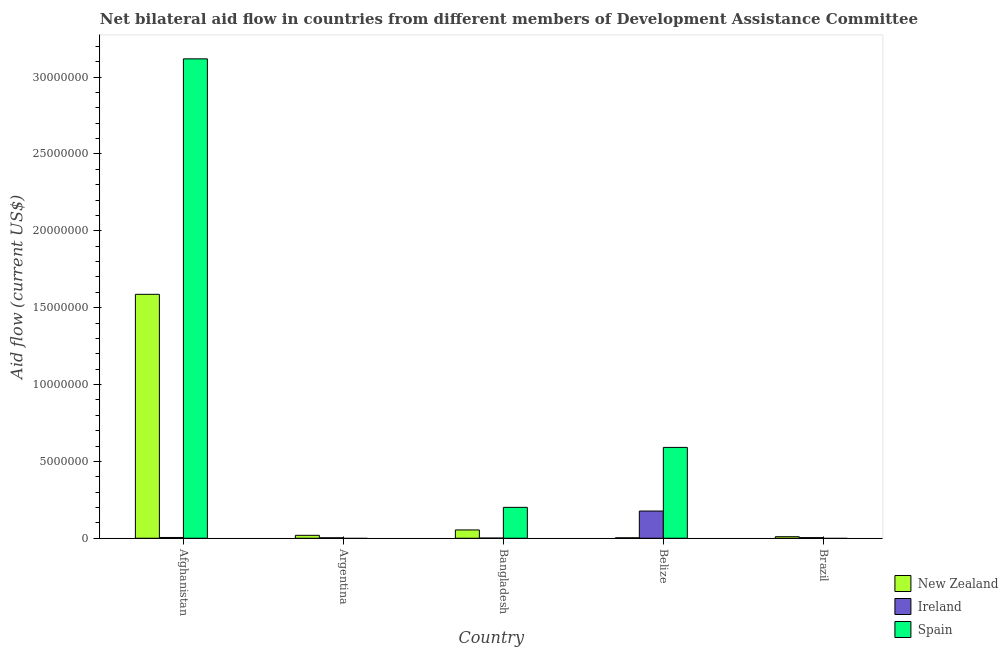How many different coloured bars are there?
Your response must be concise. 3. How many bars are there on the 1st tick from the left?
Offer a very short reply. 3. What is the label of the 5th group of bars from the left?
Ensure brevity in your answer.  Brazil. What is the amount of aid provided by spain in Argentina?
Your answer should be compact. 0. Across all countries, what is the maximum amount of aid provided by new zealand?
Your response must be concise. 1.59e+07. Across all countries, what is the minimum amount of aid provided by ireland?
Keep it short and to the point. 10000. In which country was the amount of aid provided by spain maximum?
Your response must be concise. Afghanistan. What is the total amount of aid provided by spain in the graph?
Keep it short and to the point. 3.91e+07. What is the difference between the amount of aid provided by spain in Afghanistan and that in Bangladesh?
Make the answer very short. 2.92e+07. What is the difference between the amount of aid provided by spain in Afghanistan and the amount of aid provided by new zealand in Bangladesh?
Make the answer very short. 3.06e+07. What is the average amount of aid provided by new zealand per country?
Provide a short and direct response. 3.35e+06. What is the difference between the amount of aid provided by spain and amount of aid provided by ireland in Bangladesh?
Ensure brevity in your answer.  2.00e+06. In how many countries, is the amount of aid provided by new zealand greater than 15000000 US$?
Your answer should be very brief. 1. What is the ratio of the amount of aid provided by new zealand in Afghanistan to that in Belize?
Provide a short and direct response. 529. What is the difference between the highest and the second highest amount of aid provided by new zealand?
Your answer should be compact. 1.53e+07. What is the difference between the highest and the lowest amount of aid provided by spain?
Ensure brevity in your answer.  3.12e+07. In how many countries, is the amount of aid provided by spain greater than the average amount of aid provided by spain taken over all countries?
Give a very brief answer. 1. Is it the case that in every country, the sum of the amount of aid provided by new zealand and amount of aid provided by ireland is greater than the amount of aid provided by spain?
Give a very brief answer. No. How many countries are there in the graph?
Keep it short and to the point. 5. Does the graph contain any zero values?
Keep it short and to the point. Yes. How many legend labels are there?
Ensure brevity in your answer.  3. What is the title of the graph?
Your response must be concise. Net bilateral aid flow in countries from different members of Development Assistance Committee. What is the label or title of the X-axis?
Ensure brevity in your answer.  Country. What is the Aid flow (current US$) of New Zealand in Afghanistan?
Your answer should be very brief. 1.59e+07. What is the Aid flow (current US$) of Ireland in Afghanistan?
Make the answer very short. 5.00e+04. What is the Aid flow (current US$) of Spain in Afghanistan?
Your response must be concise. 3.12e+07. What is the Aid flow (current US$) in New Zealand in Bangladesh?
Keep it short and to the point. 5.40e+05. What is the Aid flow (current US$) in Ireland in Bangladesh?
Keep it short and to the point. 10000. What is the Aid flow (current US$) in Spain in Bangladesh?
Offer a terse response. 2.01e+06. What is the Aid flow (current US$) of Ireland in Belize?
Your response must be concise. 1.77e+06. What is the Aid flow (current US$) of Spain in Belize?
Offer a terse response. 5.91e+06. What is the Aid flow (current US$) of Ireland in Brazil?
Provide a short and direct response. 4.00e+04. Across all countries, what is the maximum Aid flow (current US$) of New Zealand?
Offer a very short reply. 1.59e+07. Across all countries, what is the maximum Aid flow (current US$) of Ireland?
Offer a terse response. 1.77e+06. Across all countries, what is the maximum Aid flow (current US$) in Spain?
Your response must be concise. 3.12e+07. Across all countries, what is the minimum Aid flow (current US$) of New Zealand?
Your answer should be compact. 3.00e+04. Across all countries, what is the minimum Aid flow (current US$) of Ireland?
Your answer should be very brief. 10000. What is the total Aid flow (current US$) of New Zealand in the graph?
Keep it short and to the point. 1.67e+07. What is the total Aid flow (current US$) of Ireland in the graph?
Your response must be concise. 1.90e+06. What is the total Aid flow (current US$) of Spain in the graph?
Your answer should be very brief. 3.91e+07. What is the difference between the Aid flow (current US$) of New Zealand in Afghanistan and that in Argentina?
Your answer should be very brief. 1.57e+07. What is the difference between the Aid flow (current US$) of New Zealand in Afghanistan and that in Bangladesh?
Your answer should be very brief. 1.53e+07. What is the difference between the Aid flow (current US$) of Ireland in Afghanistan and that in Bangladesh?
Make the answer very short. 4.00e+04. What is the difference between the Aid flow (current US$) in Spain in Afghanistan and that in Bangladesh?
Offer a very short reply. 2.92e+07. What is the difference between the Aid flow (current US$) in New Zealand in Afghanistan and that in Belize?
Make the answer very short. 1.58e+07. What is the difference between the Aid flow (current US$) in Ireland in Afghanistan and that in Belize?
Provide a succinct answer. -1.72e+06. What is the difference between the Aid flow (current US$) of Spain in Afghanistan and that in Belize?
Give a very brief answer. 2.53e+07. What is the difference between the Aid flow (current US$) in New Zealand in Afghanistan and that in Brazil?
Make the answer very short. 1.58e+07. What is the difference between the Aid flow (current US$) in Ireland in Afghanistan and that in Brazil?
Your response must be concise. 10000. What is the difference between the Aid flow (current US$) of New Zealand in Argentina and that in Bangladesh?
Your answer should be compact. -3.50e+05. What is the difference between the Aid flow (current US$) of New Zealand in Argentina and that in Belize?
Your response must be concise. 1.60e+05. What is the difference between the Aid flow (current US$) in Ireland in Argentina and that in Belize?
Ensure brevity in your answer.  -1.74e+06. What is the difference between the Aid flow (current US$) in Ireland in Argentina and that in Brazil?
Your answer should be very brief. -10000. What is the difference between the Aid flow (current US$) of New Zealand in Bangladesh and that in Belize?
Provide a short and direct response. 5.10e+05. What is the difference between the Aid flow (current US$) in Ireland in Bangladesh and that in Belize?
Make the answer very short. -1.76e+06. What is the difference between the Aid flow (current US$) of Spain in Bangladesh and that in Belize?
Make the answer very short. -3.90e+06. What is the difference between the Aid flow (current US$) of Ireland in Bangladesh and that in Brazil?
Offer a very short reply. -3.00e+04. What is the difference between the Aid flow (current US$) in New Zealand in Belize and that in Brazil?
Offer a very short reply. -7.00e+04. What is the difference between the Aid flow (current US$) of Ireland in Belize and that in Brazil?
Your answer should be compact. 1.73e+06. What is the difference between the Aid flow (current US$) of New Zealand in Afghanistan and the Aid flow (current US$) of Ireland in Argentina?
Ensure brevity in your answer.  1.58e+07. What is the difference between the Aid flow (current US$) of New Zealand in Afghanistan and the Aid flow (current US$) of Ireland in Bangladesh?
Ensure brevity in your answer.  1.59e+07. What is the difference between the Aid flow (current US$) in New Zealand in Afghanistan and the Aid flow (current US$) in Spain in Bangladesh?
Give a very brief answer. 1.39e+07. What is the difference between the Aid flow (current US$) of Ireland in Afghanistan and the Aid flow (current US$) of Spain in Bangladesh?
Give a very brief answer. -1.96e+06. What is the difference between the Aid flow (current US$) of New Zealand in Afghanistan and the Aid flow (current US$) of Ireland in Belize?
Offer a very short reply. 1.41e+07. What is the difference between the Aid flow (current US$) of New Zealand in Afghanistan and the Aid flow (current US$) of Spain in Belize?
Keep it short and to the point. 9.96e+06. What is the difference between the Aid flow (current US$) of Ireland in Afghanistan and the Aid flow (current US$) of Spain in Belize?
Offer a terse response. -5.86e+06. What is the difference between the Aid flow (current US$) of New Zealand in Afghanistan and the Aid flow (current US$) of Ireland in Brazil?
Keep it short and to the point. 1.58e+07. What is the difference between the Aid flow (current US$) of New Zealand in Argentina and the Aid flow (current US$) of Ireland in Bangladesh?
Make the answer very short. 1.80e+05. What is the difference between the Aid flow (current US$) of New Zealand in Argentina and the Aid flow (current US$) of Spain in Bangladesh?
Ensure brevity in your answer.  -1.82e+06. What is the difference between the Aid flow (current US$) in Ireland in Argentina and the Aid flow (current US$) in Spain in Bangladesh?
Your answer should be compact. -1.98e+06. What is the difference between the Aid flow (current US$) of New Zealand in Argentina and the Aid flow (current US$) of Ireland in Belize?
Provide a short and direct response. -1.58e+06. What is the difference between the Aid flow (current US$) of New Zealand in Argentina and the Aid flow (current US$) of Spain in Belize?
Ensure brevity in your answer.  -5.72e+06. What is the difference between the Aid flow (current US$) in Ireland in Argentina and the Aid flow (current US$) in Spain in Belize?
Make the answer very short. -5.88e+06. What is the difference between the Aid flow (current US$) in New Zealand in Bangladesh and the Aid flow (current US$) in Ireland in Belize?
Keep it short and to the point. -1.23e+06. What is the difference between the Aid flow (current US$) of New Zealand in Bangladesh and the Aid flow (current US$) of Spain in Belize?
Your answer should be compact. -5.37e+06. What is the difference between the Aid flow (current US$) in Ireland in Bangladesh and the Aid flow (current US$) in Spain in Belize?
Your answer should be very brief. -5.90e+06. What is the difference between the Aid flow (current US$) in New Zealand in Belize and the Aid flow (current US$) in Ireland in Brazil?
Your response must be concise. -10000. What is the average Aid flow (current US$) of New Zealand per country?
Offer a terse response. 3.35e+06. What is the average Aid flow (current US$) of Ireland per country?
Your answer should be compact. 3.80e+05. What is the average Aid flow (current US$) of Spain per country?
Keep it short and to the point. 7.82e+06. What is the difference between the Aid flow (current US$) of New Zealand and Aid flow (current US$) of Ireland in Afghanistan?
Your answer should be compact. 1.58e+07. What is the difference between the Aid flow (current US$) in New Zealand and Aid flow (current US$) in Spain in Afghanistan?
Give a very brief answer. -1.53e+07. What is the difference between the Aid flow (current US$) of Ireland and Aid flow (current US$) of Spain in Afghanistan?
Your answer should be very brief. -3.11e+07. What is the difference between the Aid flow (current US$) in New Zealand and Aid flow (current US$) in Ireland in Argentina?
Keep it short and to the point. 1.60e+05. What is the difference between the Aid flow (current US$) in New Zealand and Aid flow (current US$) in Ireland in Bangladesh?
Your answer should be compact. 5.30e+05. What is the difference between the Aid flow (current US$) of New Zealand and Aid flow (current US$) of Spain in Bangladesh?
Your answer should be compact. -1.47e+06. What is the difference between the Aid flow (current US$) in Ireland and Aid flow (current US$) in Spain in Bangladesh?
Your answer should be very brief. -2.00e+06. What is the difference between the Aid flow (current US$) in New Zealand and Aid flow (current US$) in Ireland in Belize?
Your answer should be very brief. -1.74e+06. What is the difference between the Aid flow (current US$) of New Zealand and Aid flow (current US$) of Spain in Belize?
Your answer should be very brief. -5.88e+06. What is the difference between the Aid flow (current US$) in Ireland and Aid flow (current US$) in Spain in Belize?
Your answer should be compact. -4.14e+06. What is the difference between the Aid flow (current US$) in New Zealand and Aid flow (current US$) in Ireland in Brazil?
Provide a succinct answer. 6.00e+04. What is the ratio of the Aid flow (current US$) in New Zealand in Afghanistan to that in Argentina?
Make the answer very short. 83.53. What is the ratio of the Aid flow (current US$) in New Zealand in Afghanistan to that in Bangladesh?
Your response must be concise. 29.39. What is the ratio of the Aid flow (current US$) in Spain in Afghanistan to that in Bangladesh?
Give a very brief answer. 15.52. What is the ratio of the Aid flow (current US$) in New Zealand in Afghanistan to that in Belize?
Ensure brevity in your answer.  529. What is the ratio of the Aid flow (current US$) in Ireland in Afghanistan to that in Belize?
Your answer should be compact. 0.03. What is the ratio of the Aid flow (current US$) of Spain in Afghanistan to that in Belize?
Make the answer very short. 5.28. What is the ratio of the Aid flow (current US$) of New Zealand in Afghanistan to that in Brazil?
Your response must be concise. 158.7. What is the ratio of the Aid flow (current US$) in New Zealand in Argentina to that in Bangladesh?
Your answer should be very brief. 0.35. What is the ratio of the Aid flow (current US$) of Ireland in Argentina to that in Bangladesh?
Provide a succinct answer. 3. What is the ratio of the Aid flow (current US$) in New Zealand in Argentina to that in Belize?
Offer a terse response. 6.33. What is the ratio of the Aid flow (current US$) of Ireland in Argentina to that in Belize?
Your answer should be compact. 0.02. What is the ratio of the Aid flow (current US$) of New Zealand in Argentina to that in Brazil?
Your response must be concise. 1.9. What is the ratio of the Aid flow (current US$) of New Zealand in Bangladesh to that in Belize?
Your answer should be compact. 18. What is the ratio of the Aid flow (current US$) in Ireland in Bangladesh to that in Belize?
Offer a terse response. 0.01. What is the ratio of the Aid flow (current US$) of Spain in Bangladesh to that in Belize?
Offer a terse response. 0.34. What is the ratio of the Aid flow (current US$) of Ireland in Belize to that in Brazil?
Your answer should be very brief. 44.25. What is the difference between the highest and the second highest Aid flow (current US$) of New Zealand?
Make the answer very short. 1.53e+07. What is the difference between the highest and the second highest Aid flow (current US$) in Ireland?
Offer a terse response. 1.72e+06. What is the difference between the highest and the second highest Aid flow (current US$) in Spain?
Your answer should be compact. 2.53e+07. What is the difference between the highest and the lowest Aid flow (current US$) of New Zealand?
Keep it short and to the point. 1.58e+07. What is the difference between the highest and the lowest Aid flow (current US$) of Ireland?
Offer a terse response. 1.76e+06. What is the difference between the highest and the lowest Aid flow (current US$) of Spain?
Ensure brevity in your answer.  3.12e+07. 